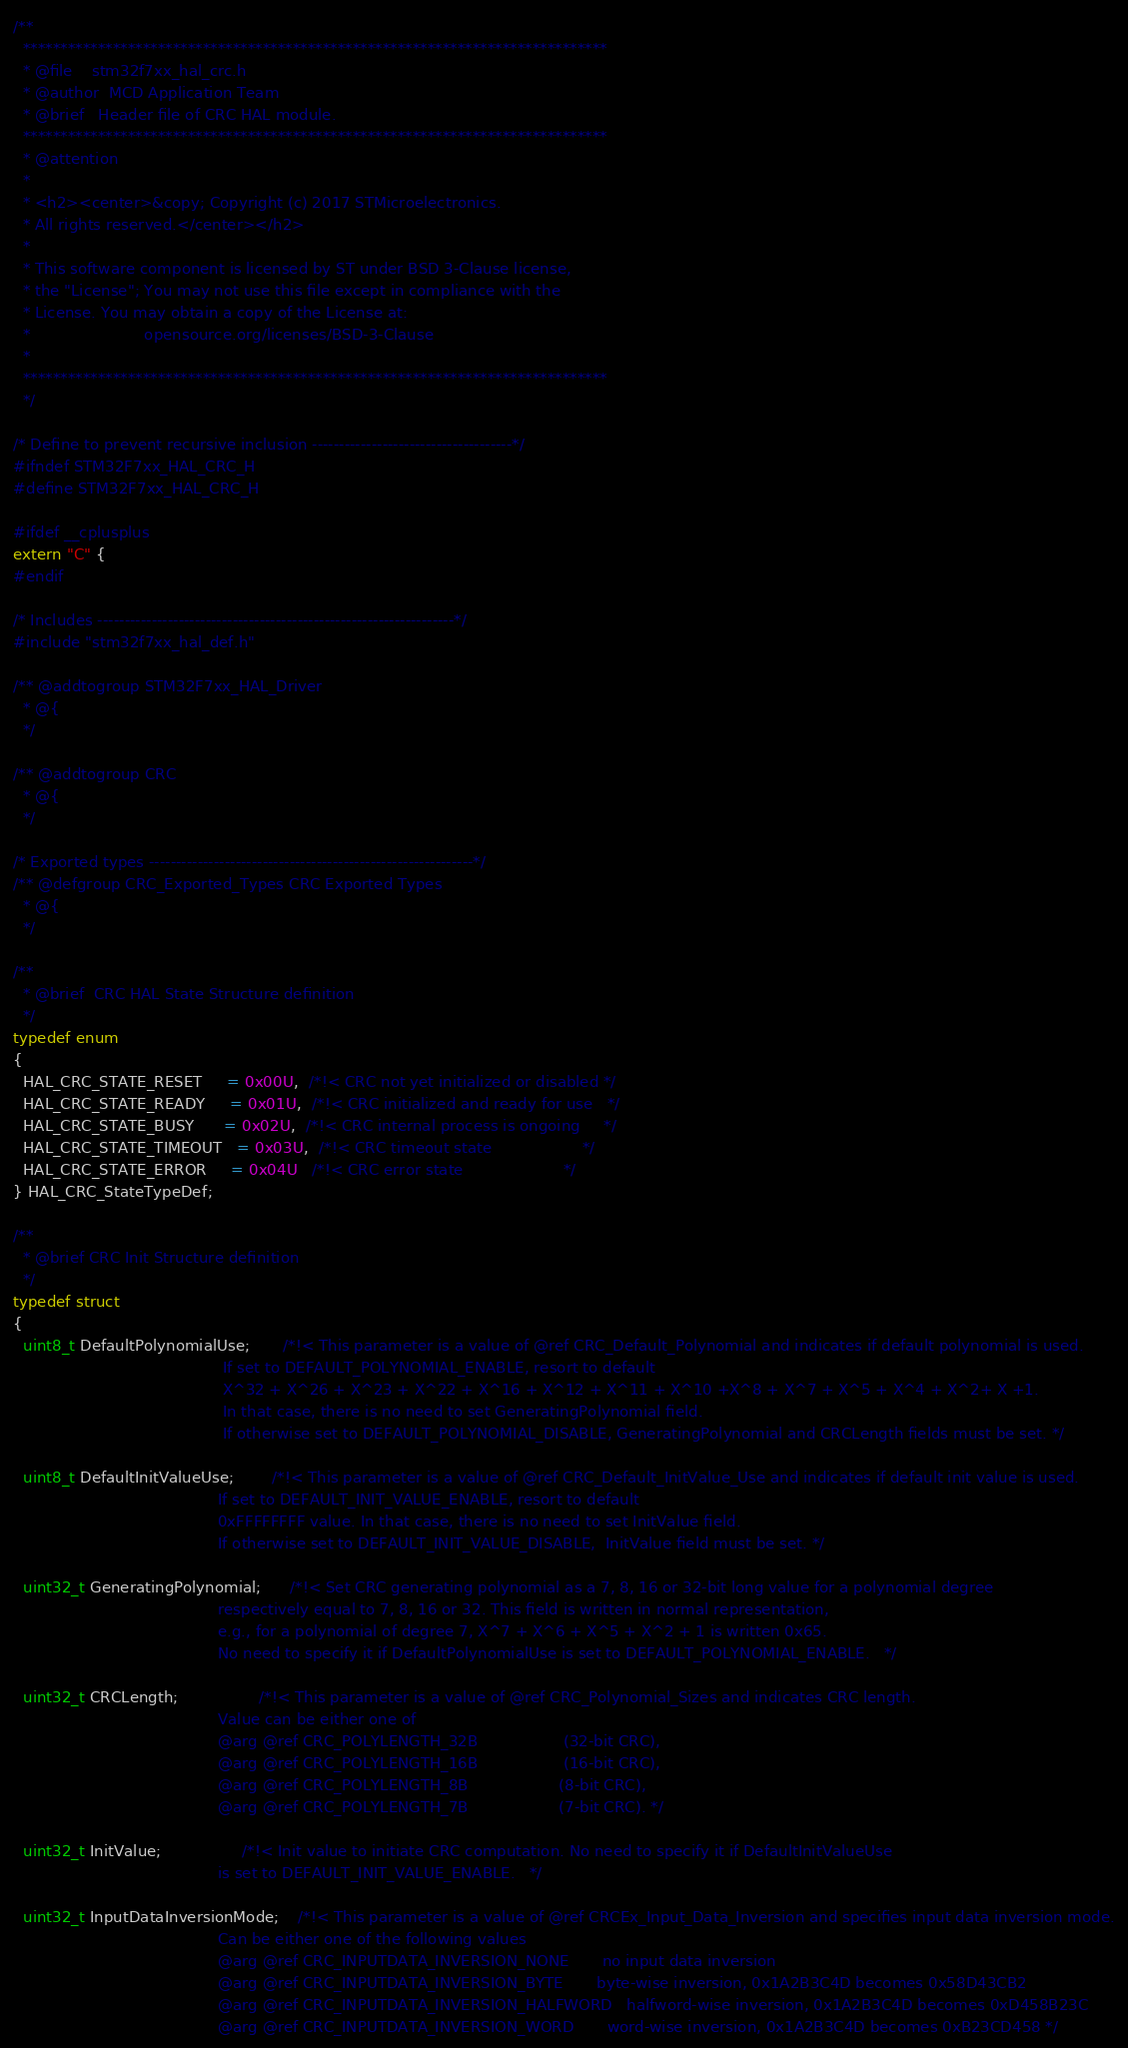<code> <loc_0><loc_0><loc_500><loc_500><_C_>/**
  ******************************************************************************
  * @file    stm32f7xx_hal_crc.h
  * @author  MCD Application Team
  * @brief   Header file of CRC HAL module.
  ******************************************************************************
  * @attention
  *
  * <h2><center>&copy; Copyright (c) 2017 STMicroelectronics.
  * All rights reserved.</center></h2>
  *
  * This software component is licensed by ST under BSD 3-Clause license,
  * the "License"; You may not use this file except in compliance with the
  * License. You may obtain a copy of the License at:
  *                        opensource.org/licenses/BSD-3-Clause
  *
  ******************************************************************************
  */

/* Define to prevent recursive inclusion -------------------------------------*/
#ifndef STM32F7xx_HAL_CRC_H
#define STM32F7xx_HAL_CRC_H

#ifdef __cplusplus
extern "C" {
#endif

/* Includes ------------------------------------------------------------------*/
#include "stm32f7xx_hal_def.h"

/** @addtogroup STM32F7xx_HAL_Driver
  * @{
  */

/** @addtogroup CRC
  * @{
  */

/* Exported types ------------------------------------------------------------*/
/** @defgroup CRC_Exported_Types CRC Exported Types
  * @{
  */

/**
  * @brief  CRC HAL State Structure definition
  */
typedef enum
{
  HAL_CRC_STATE_RESET     = 0x00U,  /*!< CRC not yet initialized or disabled */
  HAL_CRC_STATE_READY     = 0x01U,  /*!< CRC initialized and ready for use   */
  HAL_CRC_STATE_BUSY      = 0x02U,  /*!< CRC internal process is ongoing     */
  HAL_CRC_STATE_TIMEOUT   = 0x03U,  /*!< CRC timeout state                   */
  HAL_CRC_STATE_ERROR     = 0x04U   /*!< CRC error state                     */
} HAL_CRC_StateTypeDef;

/**
  * @brief CRC Init Structure definition
  */
typedef struct
{
  uint8_t DefaultPolynomialUse;       /*!< This parameter is a value of @ref CRC_Default_Polynomial and indicates if default polynomial is used.
                                            If set to DEFAULT_POLYNOMIAL_ENABLE, resort to default
                                            X^32 + X^26 + X^23 + X^22 + X^16 + X^12 + X^11 + X^10 +X^8 + X^7 + X^5 + X^4 + X^2+ X +1.
                                            In that case, there is no need to set GeneratingPolynomial field.
                                            If otherwise set to DEFAULT_POLYNOMIAL_DISABLE, GeneratingPolynomial and CRCLength fields must be set. */

  uint8_t DefaultInitValueUse;        /*!< This parameter is a value of @ref CRC_Default_InitValue_Use and indicates if default init value is used.
                                           If set to DEFAULT_INIT_VALUE_ENABLE, resort to default
                                           0xFFFFFFFF value. In that case, there is no need to set InitValue field.
                                           If otherwise set to DEFAULT_INIT_VALUE_DISABLE,  InitValue field must be set. */

  uint32_t GeneratingPolynomial;      /*!< Set CRC generating polynomial as a 7, 8, 16 or 32-bit long value for a polynomial degree
                                           respectively equal to 7, 8, 16 or 32. This field is written in normal representation,
                                           e.g., for a polynomial of degree 7, X^7 + X^6 + X^5 + X^2 + 1 is written 0x65.
                                           No need to specify it if DefaultPolynomialUse is set to DEFAULT_POLYNOMIAL_ENABLE.   */

  uint32_t CRCLength;                 /*!< This parameter is a value of @ref CRC_Polynomial_Sizes and indicates CRC length.
                                           Value can be either one of
                                           @arg @ref CRC_POLYLENGTH_32B                  (32-bit CRC),
                                           @arg @ref CRC_POLYLENGTH_16B                  (16-bit CRC),
                                           @arg @ref CRC_POLYLENGTH_8B                   (8-bit CRC),
                                           @arg @ref CRC_POLYLENGTH_7B                   (7-bit CRC). */

  uint32_t InitValue;                 /*!< Init value to initiate CRC computation. No need to specify it if DefaultInitValueUse
                                           is set to DEFAULT_INIT_VALUE_ENABLE.   */

  uint32_t InputDataInversionMode;    /*!< This parameter is a value of @ref CRCEx_Input_Data_Inversion and specifies input data inversion mode.
                                           Can be either one of the following values
                                           @arg @ref CRC_INPUTDATA_INVERSION_NONE       no input data inversion
                                           @arg @ref CRC_INPUTDATA_INVERSION_BYTE       byte-wise inversion, 0x1A2B3C4D becomes 0x58D43CB2
                                           @arg @ref CRC_INPUTDATA_INVERSION_HALFWORD   halfword-wise inversion, 0x1A2B3C4D becomes 0xD458B23C
                                           @arg @ref CRC_INPUTDATA_INVERSION_WORD       word-wise inversion, 0x1A2B3C4D becomes 0xB23CD458 */
</code> 